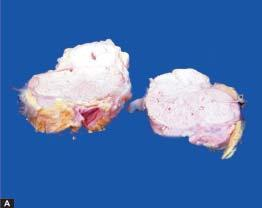s matted mass of lymph nodes surrounded by increased fat?
Answer the question using a single word or phrase. Yes 